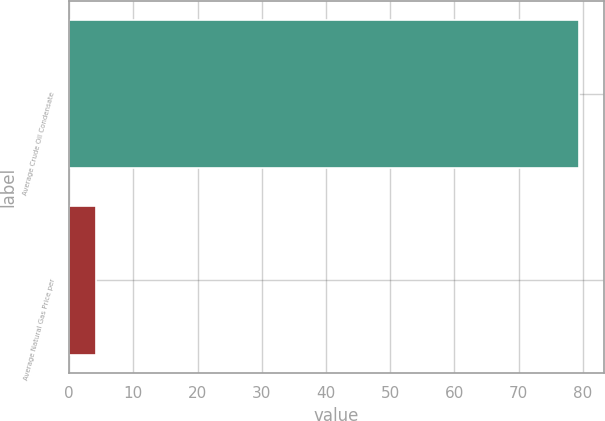Convert chart. <chart><loc_0><loc_0><loc_500><loc_500><bar_chart><fcel>Average Crude Oil Condensate<fcel>Average Natural Gas Price per<nl><fcel>79.35<fcel>4.22<nl></chart> 